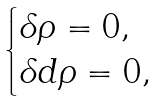Convert formula to latex. <formula><loc_0><loc_0><loc_500><loc_500>\begin{cases} \delta \rho = 0 , \\ \delta d \rho = 0 , \end{cases}</formula> 